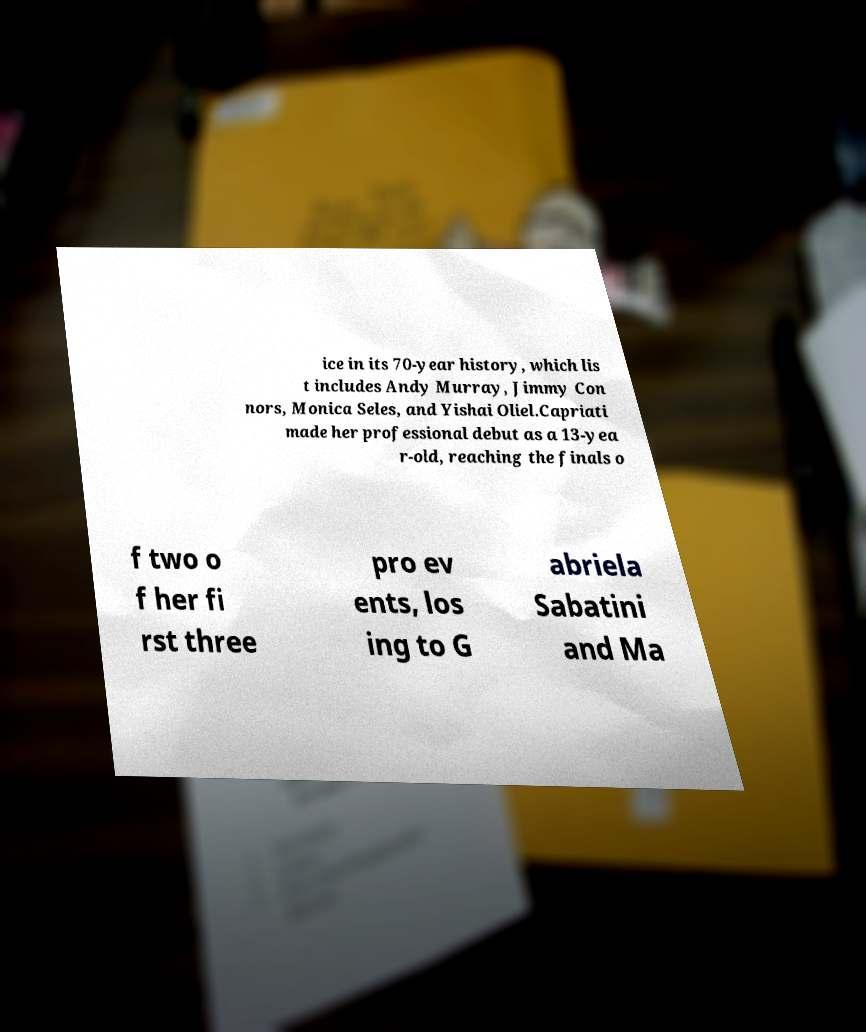Can you accurately transcribe the text from the provided image for me? ice in its 70-year history, which lis t includes Andy Murray, Jimmy Con nors, Monica Seles, and Yishai Oliel.Capriati made her professional debut as a 13-yea r-old, reaching the finals o f two o f her fi rst three pro ev ents, los ing to G abriela Sabatini and Ma 